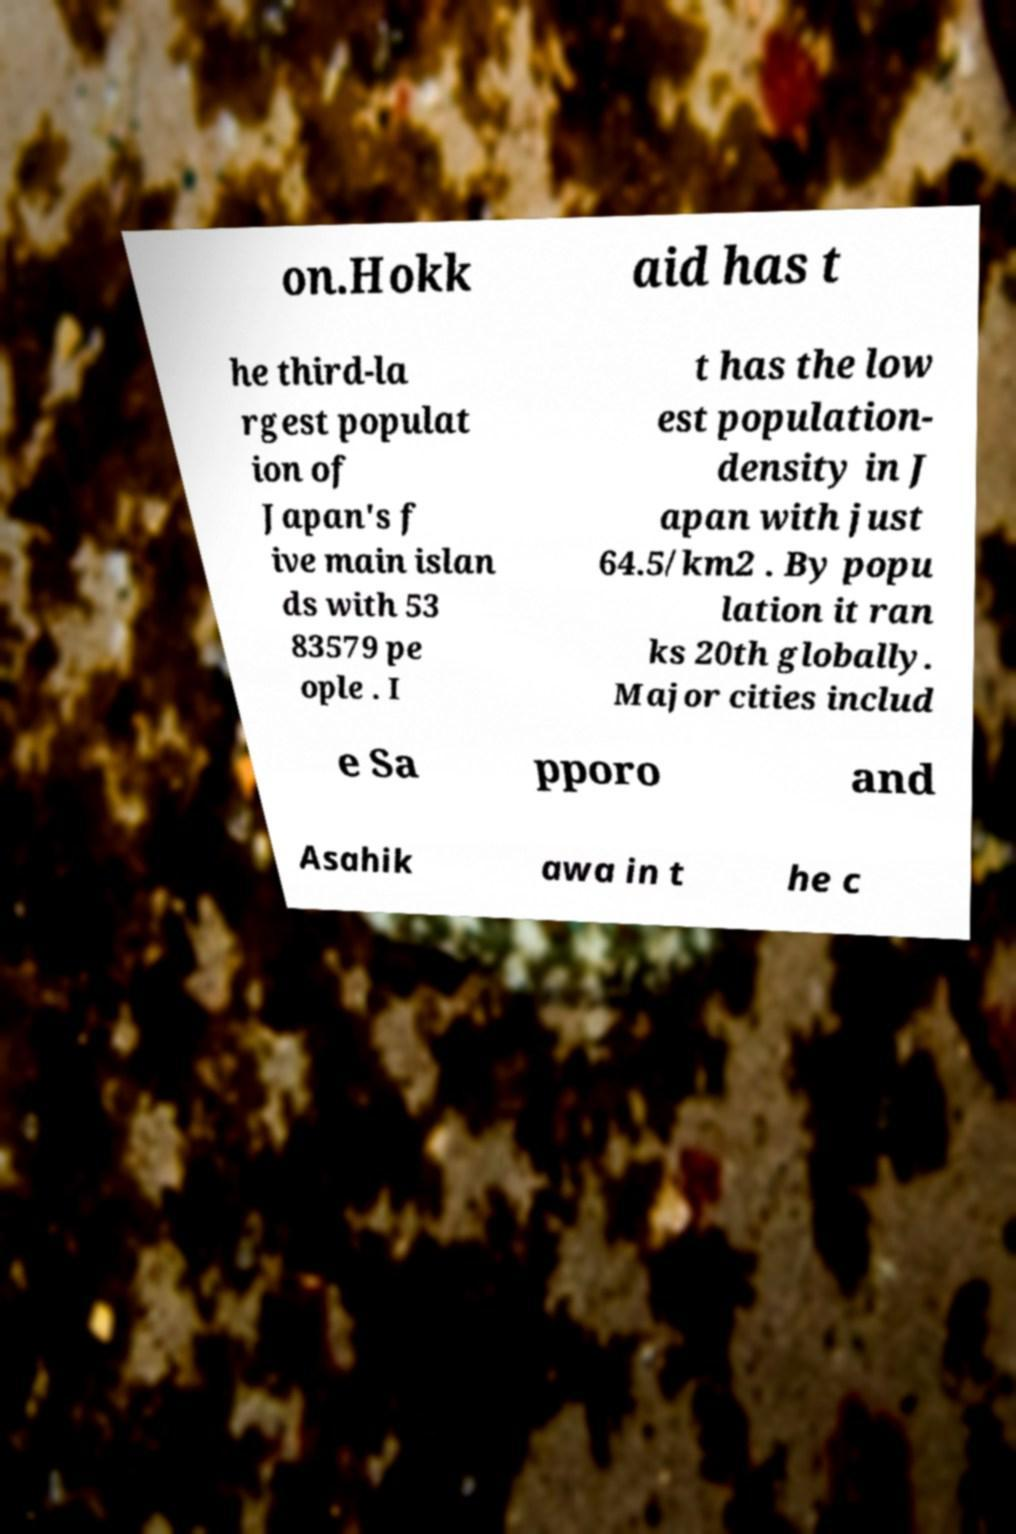Could you assist in decoding the text presented in this image and type it out clearly? on.Hokk aid has t he third-la rgest populat ion of Japan's f ive main islan ds with 53 83579 pe ople . I t has the low est population- density in J apan with just 64.5/km2 . By popu lation it ran ks 20th globally. Major cities includ e Sa pporo and Asahik awa in t he c 